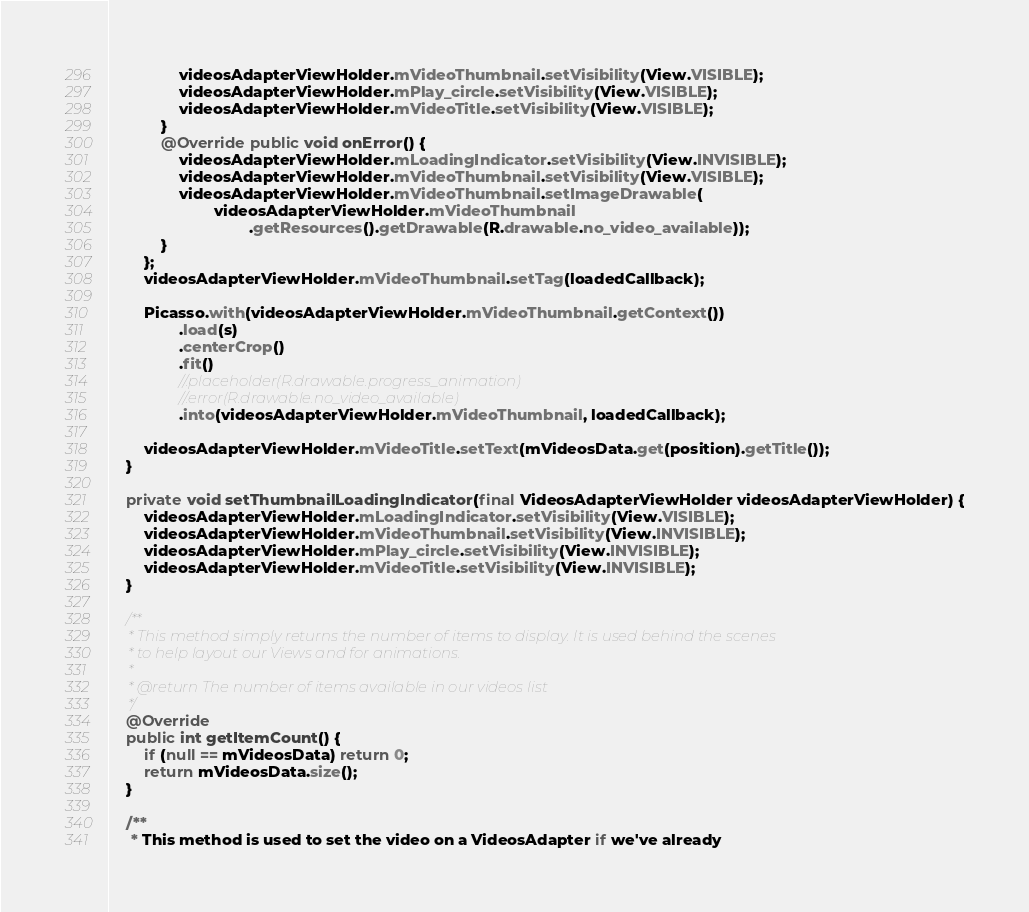<code> <loc_0><loc_0><loc_500><loc_500><_Java_>                videosAdapterViewHolder.mVideoThumbnail.setVisibility(View.VISIBLE);
                videosAdapterViewHolder.mPlay_circle.setVisibility(View.VISIBLE);
                videosAdapterViewHolder.mVideoTitle.setVisibility(View.VISIBLE);
            }
            @Override public void onError() {
                videosAdapterViewHolder.mLoadingIndicator.setVisibility(View.INVISIBLE);
                videosAdapterViewHolder.mVideoThumbnail.setVisibility(View.VISIBLE);
                videosAdapterViewHolder.mVideoThumbnail.setImageDrawable(
                        videosAdapterViewHolder.mVideoThumbnail
                                .getResources().getDrawable(R.drawable.no_video_available));
            }
        };
        videosAdapterViewHolder.mVideoThumbnail.setTag(loadedCallback);

        Picasso.with(videosAdapterViewHolder.mVideoThumbnail.getContext())
                .load(s)
                .centerCrop()
                .fit()
                //.placeholder(R.drawable.progress_animation)
                //.error(R.drawable.no_video_available)
                .into(videosAdapterViewHolder.mVideoThumbnail, loadedCallback);

        videosAdapterViewHolder.mVideoTitle.setText(mVideosData.get(position).getTitle());
    }

    private void setThumbnailLoadingIndicator(final VideosAdapterViewHolder videosAdapterViewHolder) {
        videosAdapterViewHolder.mLoadingIndicator.setVisibility(View.VISIBLE);
        videosAdapterViewHolder.mVideoThumbnail.setVisibility(View.INVISIBLE);
        videosAdapterViewHolder.mPlay_circle.setVisibility(View.INVISIBLE);
        videosAdapterViewHolder.mVideoTitle.setVisibility(View.INVISIBLE);
    }

    /**
     * This method simply returns the number of items to display. It is used behind the scenes
     * to help layout our Views and for animations.
     *
     * @return The number of items available in our videos list
     */
    @Override
    public int getItemCount() {
        if (null == mVideosData) return 0;
        return mVideosData.size();
    }

    /**
     * This method is used to set the video on a VideosAdapter if we've already</code> 